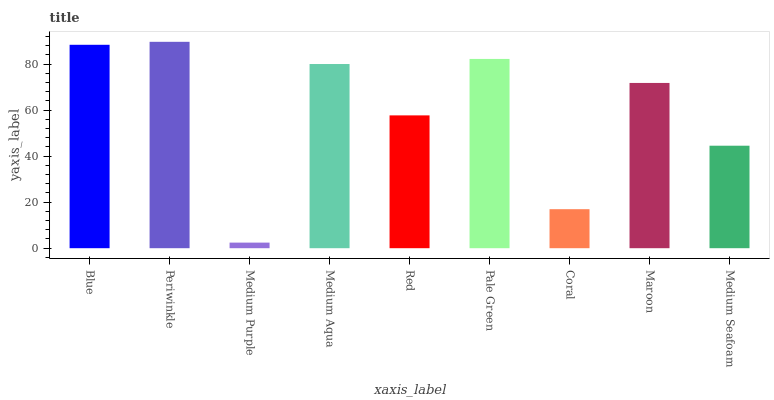Is Medium Purple the minimum?
Answer yes or no. Yes. Is Periwinkle the maximum?
Answer yes or no. Yes. Is Periwinkle the minimum?
Answer yes or no. No. Is Medium Purple the maximum?
Answer yes or no. No. Is Periwinkle greater than Medium Purple?
Answer yes or no. Yes. Is Medium Purple less than Periwinkle?
Answer yes or no. Yes. Is Medium Purple greater than Periwinkle?
Answer yes or no. No. Is Periwinkle less than Medium Purple?
Answer yes or no. No. Is Maroon the high median?
Answer yes or no. Yes. Is Maroon the low median?
Answer yes or no. Yes. Is Medium Purple the high median?
Answer yes or no. No. Is Red the low median?
Answer yes or no. No. 